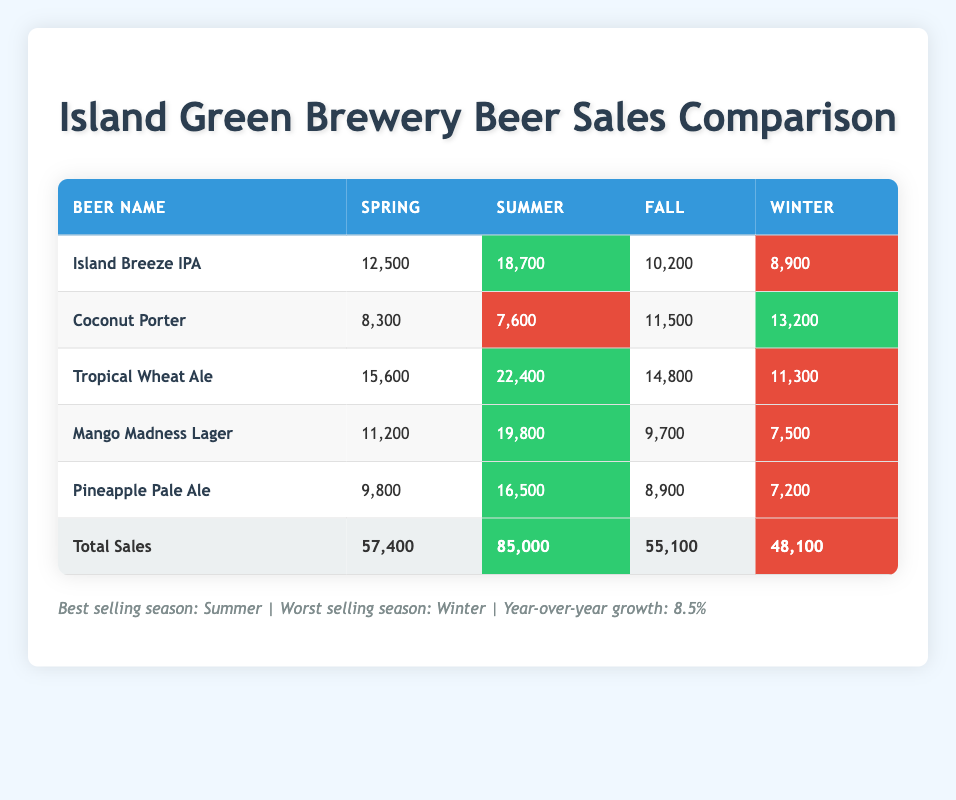What were the sales of Tropical Wheat Ale in the summer? The table shows that the summer sales for Tropical Wheat Ale were 22,400
Answer: 22,400 Which beer had the highest sales in spring? By comparing the spring sales of all beers listed, Island Breeze IPA had the highest sales at 12,500
Answer: 12,500 What is the total sales for the Winter season? The total sales for Winter are listed in the table as 48,100
Answer: 48,100 Is the sales for Coconut Porter higher in winter than in spring? The sales for Coconut Porter are 13,200 in winter and 8,300 in spring. Since 13,200 is greater than 8,300, the answer is yes
Answer: Yes What is the difference in sales between the best and worst selling season? The best selling season, Summer, has total sales of 85,000, and the worst selling season, Winter, has total sales of 48,100. The difference is 85,000 - 48,100 = 36,900
Answer: 36,900 How many beers sold more than 15,000 in the summer? From the table, the beers that sold more than 15,000 in the summer are Tropical Wheat Ale (22,400), Island Breeze IPA (18,700), and Mango Madness Lager (19,800). This means 3 beers had sales over 15,000
Answer: 3 What were the combined sales of Island Breeze IPA and Tropical Wheat Ale in Fall? The sales for Island Breeze IPA in Fall was 10,200 and for Tropical Wheat Ale was 14,800. Adding these together gives 10,200 + 14,800 = 25,000
Answer: 25,000 Did the sales of Mango Madness Lager decrease from Summer to Winter? The sales for Mango Madness Lager were 19,800 in Summer and 7,500 in Winter. Since 7,500 is less than 19,800, the answer is yes
Answer: Yes 